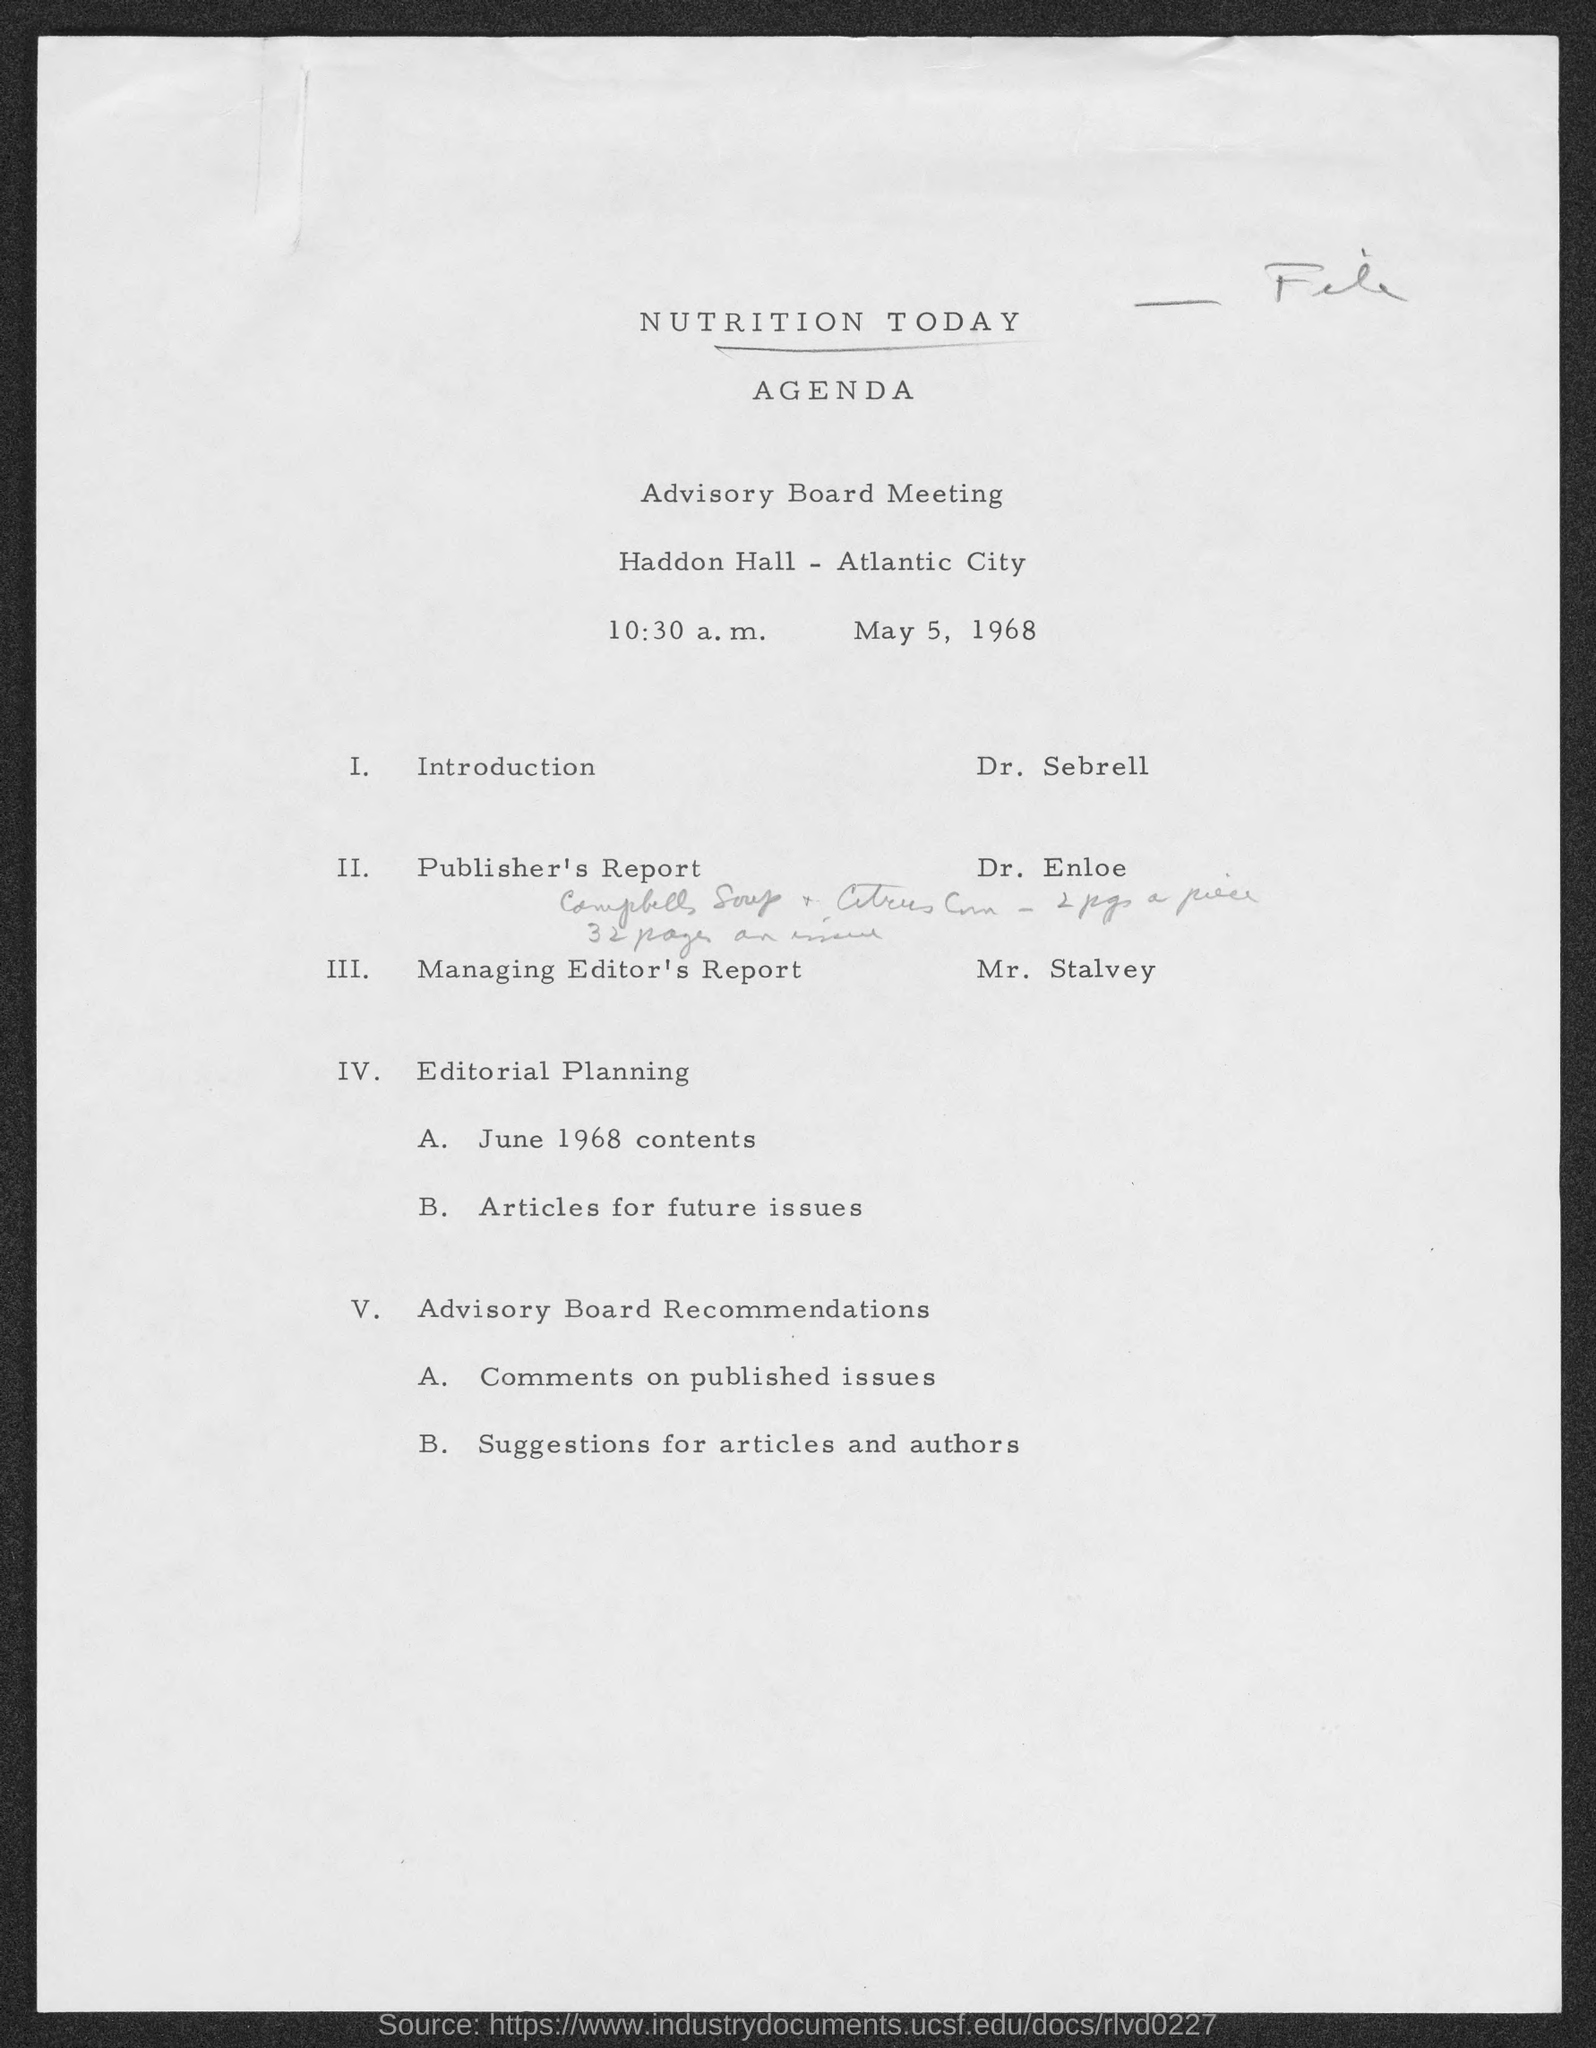Give some essential details in this illustration. The meeting will commence at 10:30 a.m. It is announced that Dr. Sebrell will give the introduction. Mr. Stalvey is discussing a report on managing, which is the process of overseeing and coordinating various aspects of a project or organization. 